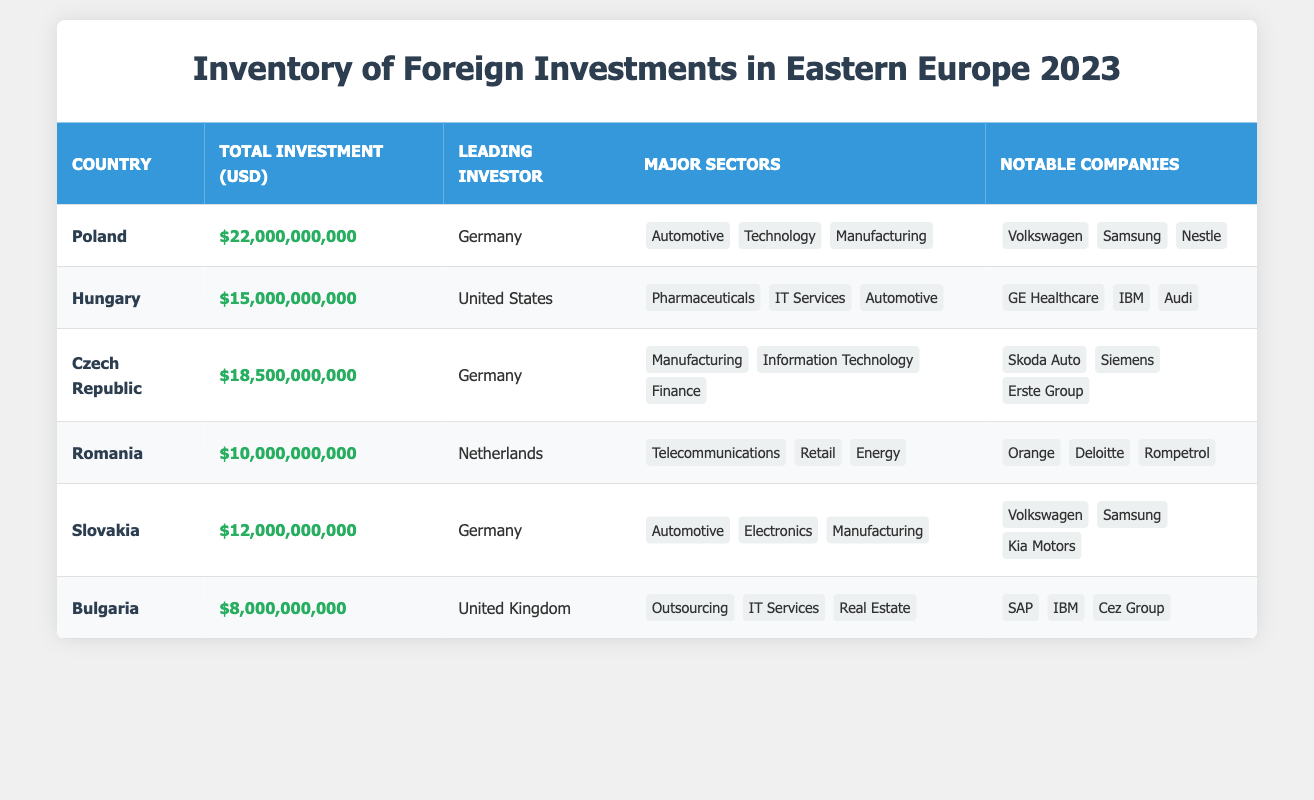What is the total investment in Poland? The table lists Poland with a total investment of 22,000,000,000 USD in the corresponding row.
Answer: 22,000,000,000 USD Which country has the highest total investment? By comparing the total investment of all countries listed, Poland has the highest investment at 22,000,000,000 USD.
Answer: Poland How many major sectors are there in Hungary? Hungary lists three major sectors: Pharmaceuticals, IT Services, and Automotive. Therefore, the count is three.
Answer: 3 Which country is the leading investor in Romania? According to the table, the leading investor in Romania is the Netherlands.
Answer: Netherlands What is the sum of total investments for Bulgaria and Romania? For Bulgaria, the total investment is 8,000,000,000 USD and for Romania it is 10,000,000,000 USD. Therefore, the sum is 8,000,000,000 + 10,000,000,000 = 18,000,000,000 USD.
Answer: 18,000,000,000 USD Is the leading investor in the Czech Republic also the leading investor in Slovakia? The Czech Republic has Germany as its leading investor, and Slovakia also lists Germany as its leading investor. Therefore, the answer is yes.
Answer: Yes Which sector does not appear in any of the countries listed? By reviewing the major sectors for all countries, sectors like Agriculture, Construction, and Mining do not appear in any of the entries listed in the table. This can be confirmed upon examination.
Answer: Agriculture, Construction, Mining What is the average total investment across all listed countries? The total investments are as follows: Poland - 22,000,000,000, Hungary - 15,000,000,000, Czech Republic - 18,500,000,000, Romania - 10,000,000,000, Slovakia - 12,000,000,000, Bulgaria - 8,000,000,000. Adding these gives 22,000,000,000 + 15,000,000,000 + 18,500,000,000 + 10,000,000,000 + 12,000,000,000 + 8,000,000,000 = 85,500,000,000 USD. There are 6 countries, so the average is 85,500,000,000 / 6 = 14,250,000,000 USD.
Answer: 14,250,000,000 USD What major sector is common to both Poland and Slovakia? The major sector "Automotive" is listed in the sectors for both Poland and Slovakia, indicating a shared focus in this area between the two countries.
Answer: Automotive 